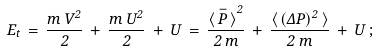Convert formula to latex. <formula><loc_0><loc_0><loc_500><loc_500>\, E _ { t } \, = \, \frac { m \, V ^ { 2 } } { 2 } \, + \, \frac { m \, U ^ { 2 } } { 2 } \, + \, U \, = \, \frac { { \langle \, \bar { P } \, \rangle } ^ { 2 } } { 2 \, m } \, + \, \frac { \langle \, ( \Delta P ) ^ { 2 } \, \rangle } { 2 \, m } \, + \, U \, ;</formula> 